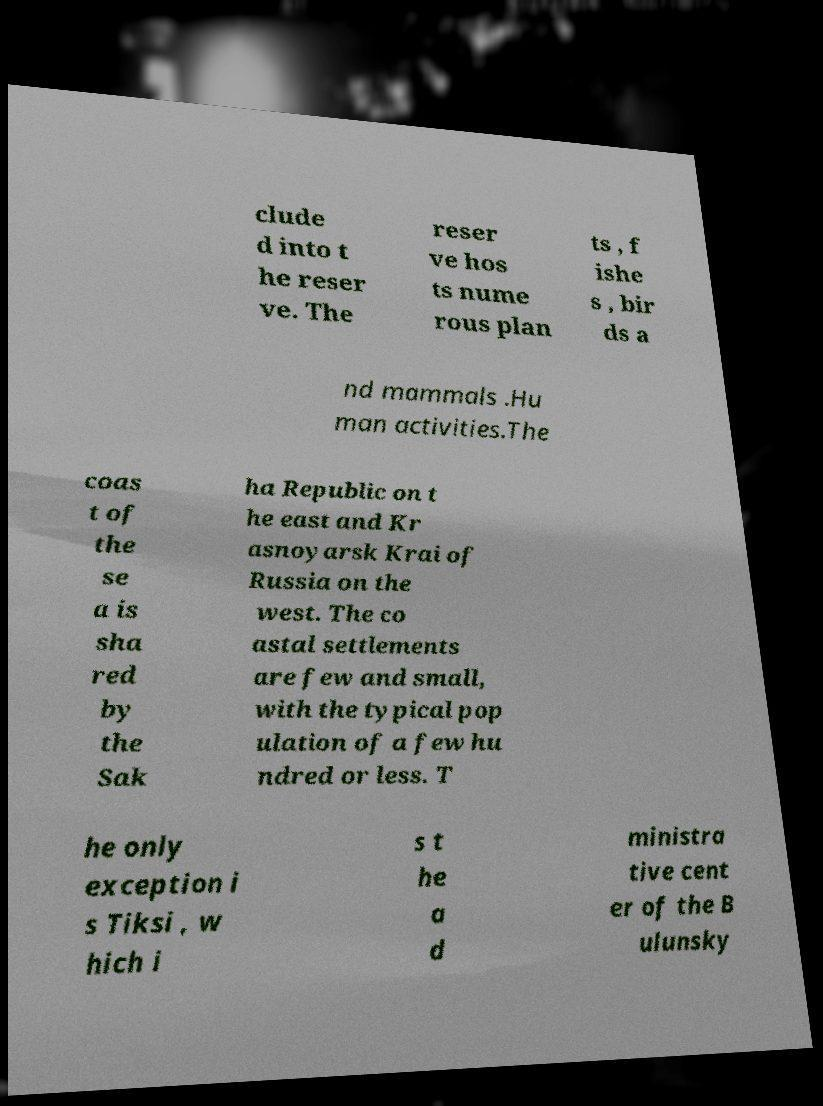Could you assist in decoding the text presented in this image and type it out clearly? clude d into t he reser ve. The reser ve hos ts nume rous plan ts , f ishe s , bir ds a nd mammals .Hu man activities.The coas t of the se a is sha red by the Sak ha Republic on t he east and Kr asnoyarsk Krai of Russia on the west. The co astal settlements are few and small, with the typical pop ulation of a few hu ndred or less. T he only exception i s Tiksi , w hich i s t he a d ministra tive cent er of the B ulunsky 